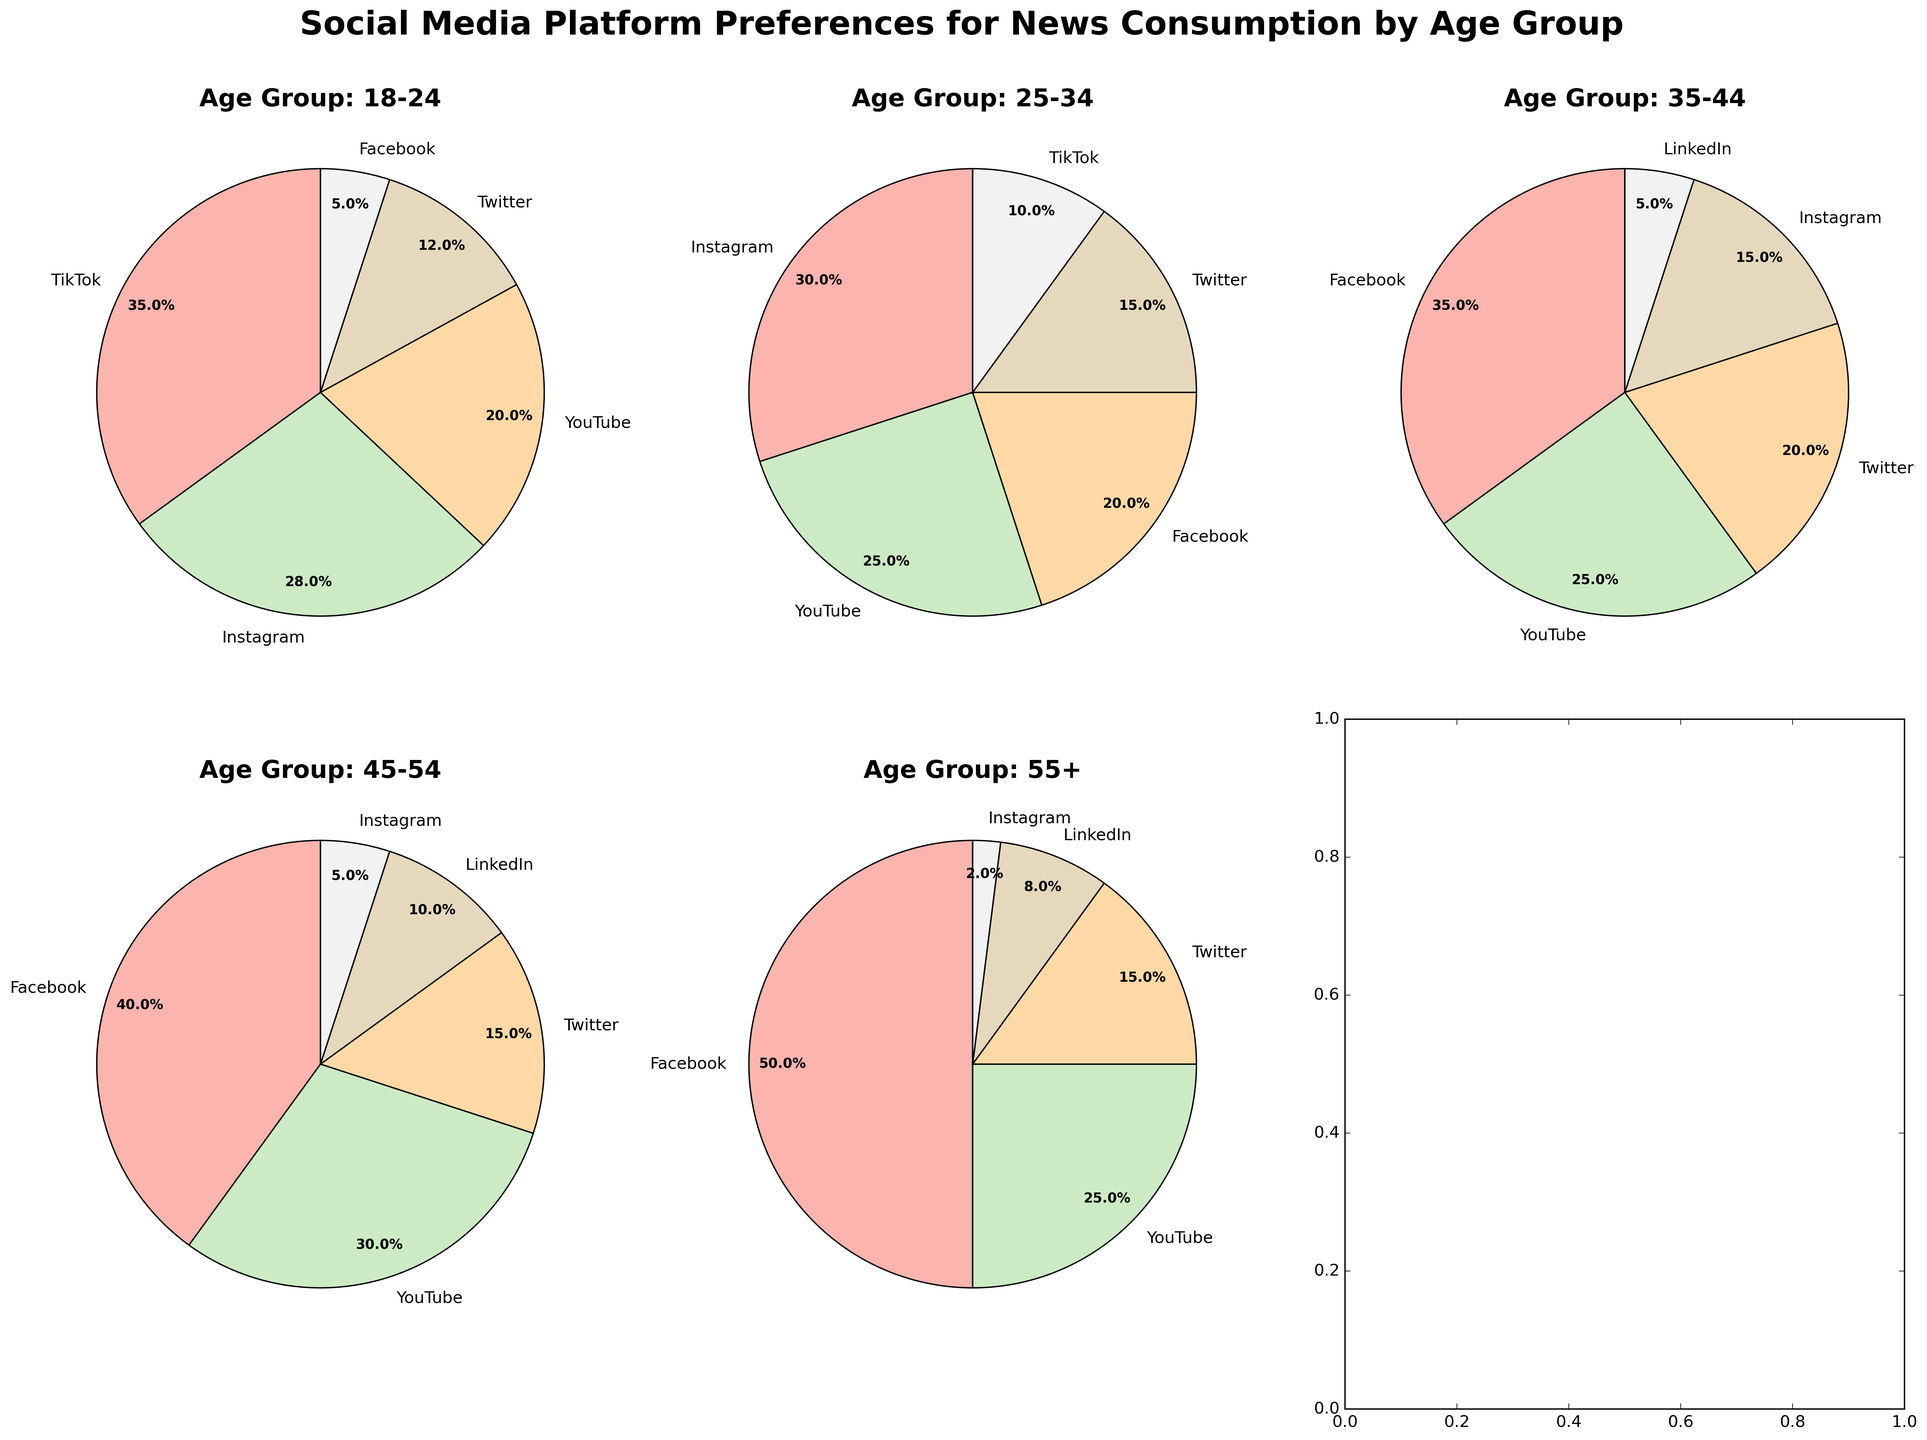Which social media platform is most preferred for news consumption among the 18-24 age group? In the pie chart for the 18-24 age group, TikTok has the largest segment, indicating it is the most preferred platform.
Answer: TikTok What is the least preferred social media platform for the 55+ age group? In the pie chart for the 55+ age group, Instagram has the smallest segment, making it the least preferred platform.
Answer: Instagram Which age group has the highest preference for Facebook for news consumption? By examining the pie charts, the 55+ age group has the largest segment for Facebook compared to other age groups.
Answer: 55+ Among the 25-34 age group, what is the combined percentage of people who prefer YouTube and Facebook for news consumption? YouTube accounts for 25% and Facebook for 20%. Adding these gives 25% + 20% = 45%.
Answer: 45% Which age group shows the most diverse preference across different social media platforms? The diversity of preference can be seen by comparing the spread of percentages across platforms. The 18-24 age group shows a more balanced distribution without one platform hugely dominating over others.
Answer: 18-24 How does the percentage of Twitter preference in the 35-44 age group compare to that in the 45-54 age group? In the 35-44 age group, Twitter accounts for 20%, while in the 45-54 age group, it is 15%. Thus, the percentage is higher in the 35-44 age group.
Answer: Higher in 35-44 What percentage difference is there between Facebook preference in the 18-24 age group and the 55+ age group? Facebook preference is 5% in the 18-24 age group and 50% in the 55+ age group. The difference is 50% - 5% = 45%.
Answer: 45% What is the average preference percentage for YouTube across all age groups? Sum the percentages for YouTube across age groups: 20% + 25% + 25% + 30% + 25% = 125%. There are 5 age groups, so 125% / 5 = 25%.
Answer: 25% Which social media platform shows a decreasing trend of preference with increasing age groups? By comparing each platform across age groups, TikTok shows a decreasing trend: 35% (18-24), 10% (25-34), 0% (35-44), and 0% (45-54 and 55+).
Answer: TikTok 